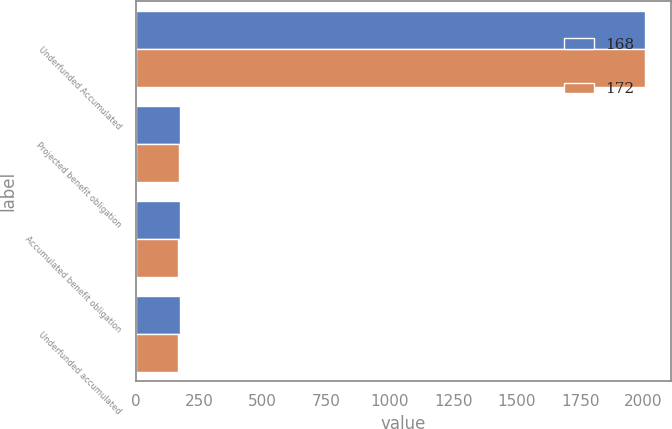Convert chart to OTSL. <chart><loc_0><loc_0><loc_500><loc_500><stacked_bar_chart><ecel><fcel>Underfunded Accumulated<fcel>Projected benefit obligation<fcel>Accumulated benefit obligation<fcel>Underfunded accumulated<nl><fcel>168<fcel>2007<fcel>175<fcel>172<fcel>172<nl><fcel>172<fcel>2006<fcel>169<fcel>168<fcel>168<nl></chart> 